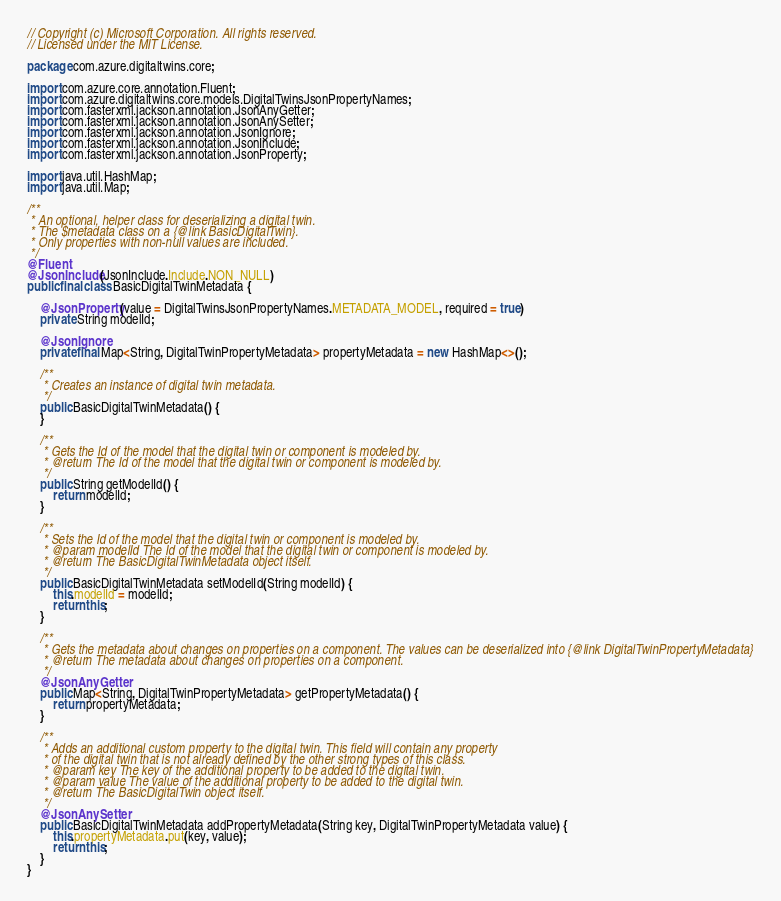Convert code to text. <code><loc_0><loc_0><loc_500><loc_500><_Java_>// Copyright (c) Microsoft Corporation. All rights reserved.
// Licensed under the MIT License.

package com.azure.digitaltwins.core;

import com.azure.core.annotation.Fluent;
import com.azure.digitaltwins.core.models.DigitalTwinsJsonPropertyNames;
import com.fasterxml.jackson.annotation.JsonAnyGetter;
import com.fasterxml.jackson.annotation.JsonAnySetter;
import com.fasterxml.jackson.annotation.JsonIgnore;
import com.fasterxml.jackson.annotation.JsonInclude;
import com.fasterxml.jackson.annotation.JsonProperty;

import java.util.HashMap;
import java.util.Map;

/**
 * An optional, helper class for deserializing a digital twin.
 * The $metadata class on a {@link BasicDigitalTwin}.
 * Only properties with non-null values are included.
 */
@Fluent
@JsonInclude(JsonInclude.Include.NON_NULL)
public final class BasicDigitalTwinMetadata {

    @JsonProperty(value = DigitalTwinsJsonPropertyNames.METADATA_MODEL, required = true)
    private String modelId;

    @JsonIgnore
    private final Map<String, DigitalTwinPropertyMetadata> propertyMetadata = new HashMap<>();

    /**
     * Creates an instance of digital twin metadata.
     */
    public BasicDigitalTwinMetadata() {
    }

    /**
     * Gets the Id of the model that the digital twin or component is modeled by.
     * @return The Id of the model that the digital twin or component is modeled by.
     */
    public String getModelId() {
        return modelId;
    }

    /**
     * Sets the Id of the model that the digital twin or component is modeled by.
     * @param modelId The Id of the model that the digital twin or component is modeled by.
     * @return The BasicDigitalTwinMetadata object itself.
     */
    public BasicDigitalTwinMetadata setModelId(String modelId) {
        this.modelId = modelId;
        return this;
    }

    /**
     * Gets the metadata about changes on properties on a component. The values can be deserialized into {@link DigitalTwinPropertyMetadata}
     * @return The metadata about changes on properties on a component.
     */
    @JsonAnyGetter
    public Map<String, DigitalTwinPropertyMetadata> getPropertyMetadata() {
        return propertyMetadata;
    }

    /**
     * Adds an additional custom property to the digital twin. This field will contain any property
     * of the digital twin that is not already defined by the other strong types of this class.
     * @param key The key of the additional property to be added to the digital twin.
     * @param value The value of the additional property to be added to the digital twin.
     * @return The BasicDigitalTwin object itself.
     */
    @JsonAnySetter
    public BasicDigitalTwinMetadata addPropertyMetadata(String key, DigitalTwinPropertyMetadata value) {
        this.propertyMetadata.put(key, value);
        return this;
    }
}
</code> 